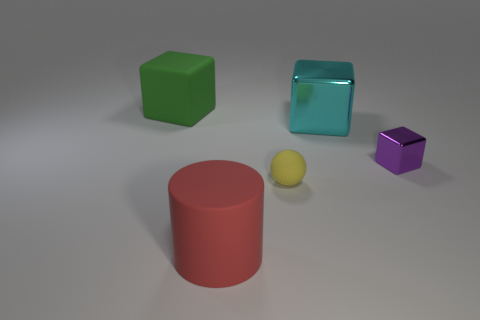What number of other things are there of the same material as the tiny purple object
Give a very brief answer. 1. What number of big objects are left of the large rubber object in front of the matte thing behind the ball?
Keep it short and to the point. 1. How many matte things are small brown balls or big cylinders?
Your response must be concise. 1. What size is the block that is to the left of the large matte object that is in front of the small rubber sphere?
Offer a terse response. Large. There is a big thing that is on the left side of the yellow object and behind the big matte cylinder; what color is it?
Ensure brevity in your answer.  Green. Is the large green object made of the same material as the cylinder?
Keep it short and to the point. Yes. How many large things are matte cubes or gray metallic objects?
Ensure brevity in your answer.  1. Is there any other thing that is the same shape as the yellow matte thing?
Make the answer very short. No. There is a thing that is made of the same material as the large cyan block; what is its color?
Your answer should be compact. Purple. There is a large rubber object that is right of the large matte block; what color is it?
Make the answer very short. Red. 